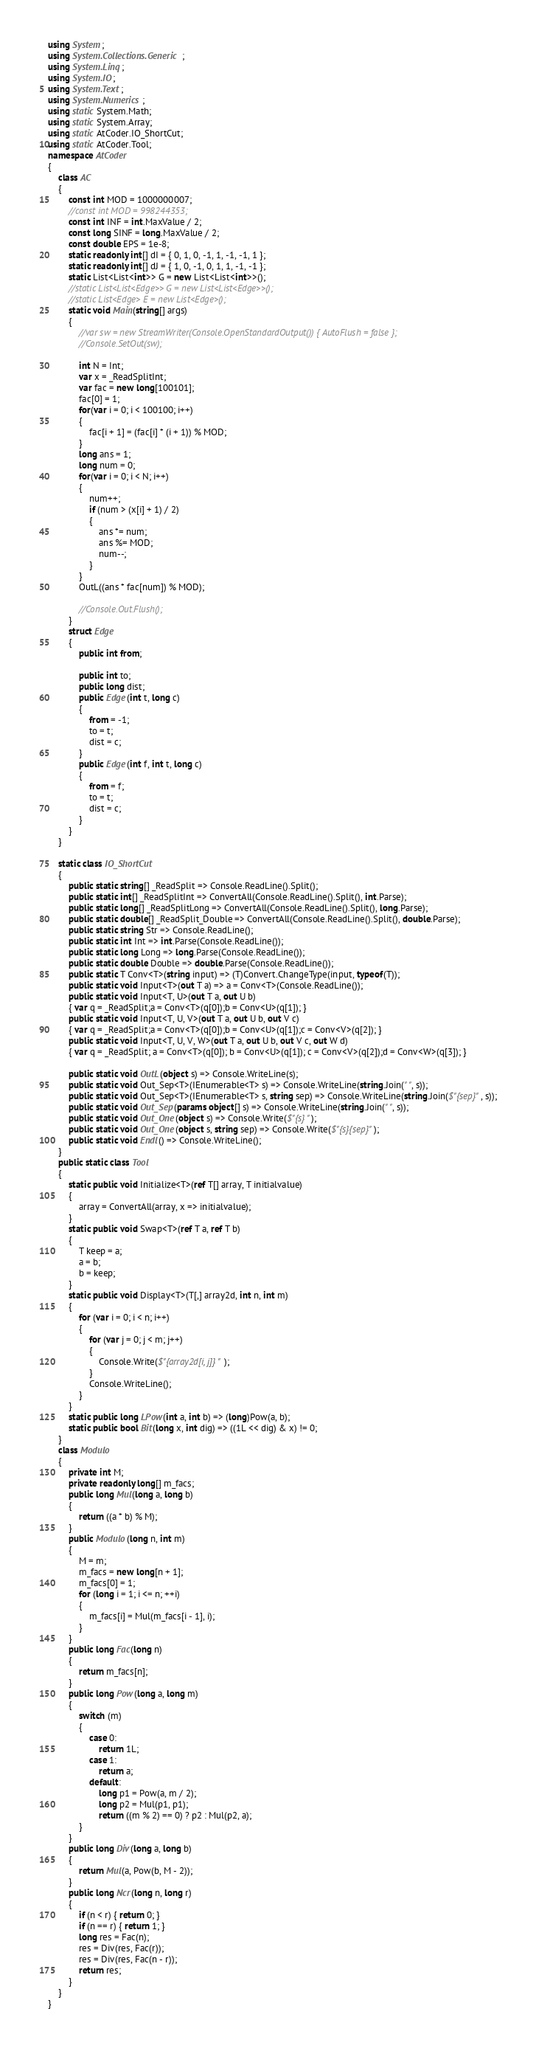<code> <loc_0><loc_0><loc_500><loc_500><_C#_>using System;
using System.Collections.Generic;
using System.Linq;
using System.IO;
using System.Text;
using System.Numerics;
using static System.Math;
using static System.Array;
using static AtCoder.IO_ShortCut;
using static AtCoder.Tool;
namespace AtCoder
{
    class AC
    {
        const int MOD = 1000000007;
        //const int MOD = 998244353;
        const int INF = int.MaxValue / 2;
        const long SINF = long.MaxValue / 2;
        const double EPS = 1e-8;
        static readonly int[] dI = { 0, 1, 0, -1, 1, -1, -1, 1 };
        static readonly int[] dJ = { 1, 0, -1, 0, 1, 1, -1, -1 };
        static List<List<int>> G = new List<List<int>>();
        //static List<List<Edge>> G = new List<List<Edge>>();
        //static List<Edge> E = new List<Edge>();
        static void Main(string[] args)
        {
            //var sw = new StreamWriter(Console.OpenStandardOutput()) { AutoFlush = false };
            //Console.SetOut(sw);

            int N = Int;
            var x = _ReadSplitInt;
            var fac = new long[100101];
            fac[0] = 1;
            for(var i = 0; i < 100100; i++)
            {
                fac[i + 1] = (fac[i] * (i + 1)) % MOD;
            }
            long ans = 1;
            long num = 0;
            for(var i = 0; i < N; i++)
            {
                num++;
                if (num > (x[i] + 1) / 2)
                {
                    ans *= num;
                    ans %= MOD;
                    num--;
                }
            }
            OutL((ans * fac[num]) % MOD);

            //Console.Out.Flush();
        }
        struct Edge
        {
            public int from;

            public int to;
            public long dist;
            public Edge(int t, long c)
            {
                from = -1;
                to = t;
                dist = c;
            }
            public Edge(int f, int t, long c)
            {
                from = f;
                to = t;
                dist = c;
            }
        }
    }
    
    static class IO_ShortCut
    {
        public static string[] _ReadSplit => Console.ReadLine().Split();
        public static int[] _ReadSplitInt => ConvertAll(Console.ReadLine().Split(), int.Parse);
        public static long[] _ReadSplitLong => ConvertAll(Console.ReadLine().Split(), long.Parse);
        public static double[] _ReadSplit_Double => ConvertAll(Console.ReadLine().Split(), double.Parse);
        public static string Str => Console.ReadLine();
        public static int Int => int.Parse(Console.ReadLine());
        public static long Long => long.Parse(Console.ReadLine());
        public static double Double => double.Parse(Console.ReadLine());
        public static T Conv<T>(string input) => (T)Convert.ChangeType(input, typeof(T));
        public static void Input<T>(out T a) => a = Conv<T>(Console.ReadLine());
        public static void Input<T, U>(out T a, out U b)
        { var q = _ReadSplit;a = Conv<T>(q[0]);b = Conv<U>(q[1]); }
        public static void Input<T, U, V>(out T a, out U b, out V c)
        { var q = _ReadSplit;a = Conv<T>(q[0]);b = Conv<U>(q[1]);c = Conv<V>(q[2]); }
        public static void Input<T, U, V, W>(out T a, out U b, out V c, out W d)
        { var q = _ReadSplit; a = Conv<T>(q[0]); b = Conv<U>(q[1]); c = Conv<V>(q[2]);d = Conv<W>(q[3]); }

        public static void OutL(object s) => Console.WriteLine(s);
        public static void Out_Sep<T>(IEnumerable<T> s) => Console.WriteLine(string.Join(" ", s));
        public static void Out_Sep<T>(IEnumerable<T> s, string sep) => Console.WriteLine(string.Join($"{sep}", s));
        public static void Out_Sep(params object[] s) => Console.WriteLine(string.Join(" ", s));
        public static void Out_One(object s) => Console.Write($"{s} ");
        public static void Out_One(object s, string sep) => Console.Write($"{s}{sep}");
        public static void Endl() => Console.WriteLine();
    }
    public static class Tool
    {
        static public void Initialize<T>(ref T[] array, T initialvalue)
        {
            array = ConvertAll(array, x => initialvalue);
        }
        static public void Swap<T>(ref T a, ref T b)
        {
            T keep = a;
            a = b;
            b = keep;
        }
        static public void Display<T>(T[,] array2d, int n, int m)
        {
            for (var i = 0; i < n; i++)
            {
                for (var j = 0; j < m; j++)
                {
                    Console.Write($"{array2d[i, j]} ");
                }
                Console.WriteLine();
            }
        }
        static public long LPow(int a, int b) => (long)Pow(a, b);
        static public bool Bit(long x, int dig) => ((1L << dig) & x) != 0;
    }
    class Modulo
    {
        private int M;
        private readonly long[] m_facs;
        public long Mul(long a, long b)
        {
            return ((a * b) % M);
        }
        public Modulo(long n, int m)
        {
            M = m;
            m_facs = new long[n + 1];
            m_facs[0] = 1;
            for (long i = 1; i <= n; ++i)
            {
                m_facs[i] = Mul(m_facs[i - 1], i);
            }
        }
        public long Fac(long n)
        {
            return m_facs[n];
        }
        public long Pow(long a, long m)
        {
            switch (m)
            {
                case 0:
                    return 1L;
                case 1:
                    return a;
                default:
                    long p1 = Pow(a, m / 2);
                    long p2 = Mul(p1, p1);
                    return ((m % 2) == 0) ? p2 : Mul(p2, a);
            }
        }
        public long Div(long a, long b)
        {
            return Mul(a, Pow(b, M - 2));
        }
        public long Ncr(long n, long r)
        {
            if (n < r) { return 0; }
            if (n == r) { return 1; }
            long res = Fac(n);
            res = Div(res, Fac(r));
            res = Div(res, Fac(n - r));
            return res;
        }
    }
}
</code> 